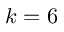<formula> <loc_0><loc_0><loc_500><loc_500>k = 6</formula> 